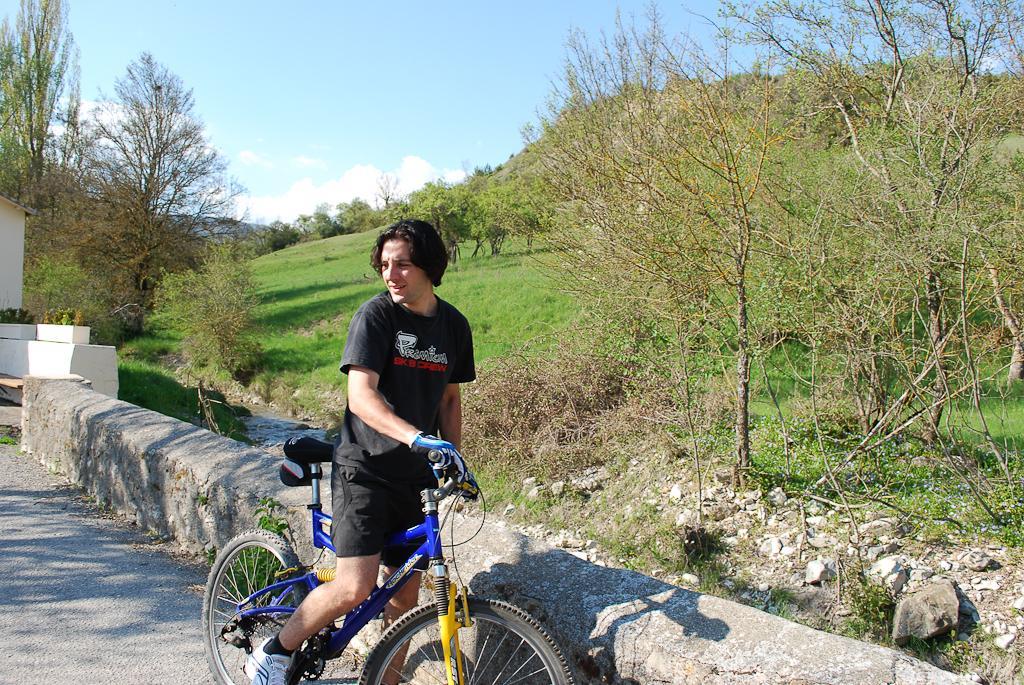In one or two sentences, can you explain what this image depicts? This is a picture taken in the outdoors. It is sunny. The man in black t shirt holding the bicycle. Background of this man is tree, sky with clouds and a wall. 